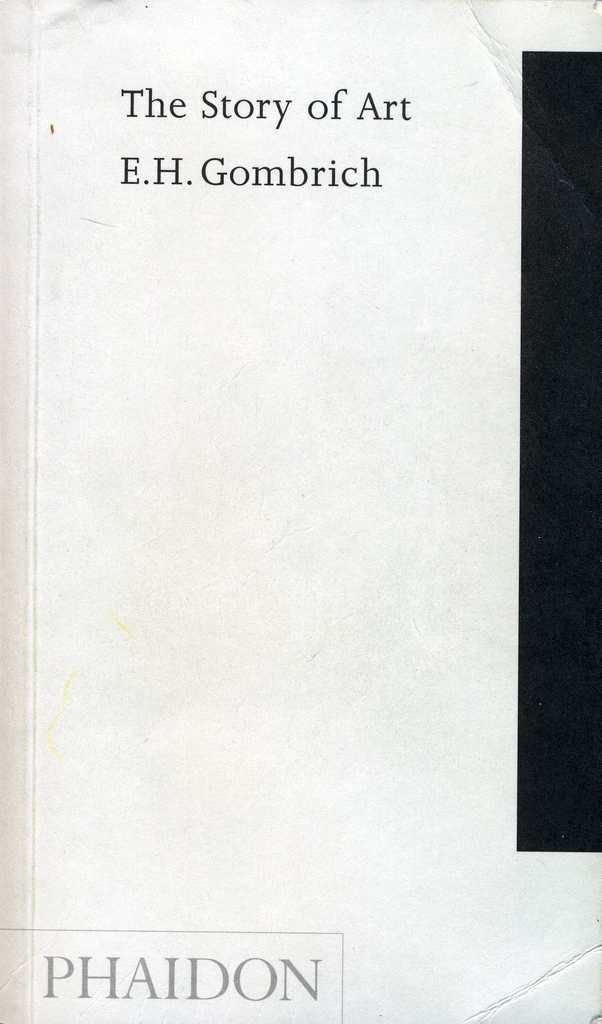<image>
Relay a brief, clear account of the picture shown. A book by E.H Gombrich and the title is The Story of Art. 